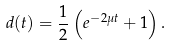Convert formula to latex. <formula><loc_0><loc_0><loc_500><loc_500>d ( t ) = \frac { 1 } { 2 } \left ( e ^ { - 2 \mu t } + 1 \right ) .</formula> 